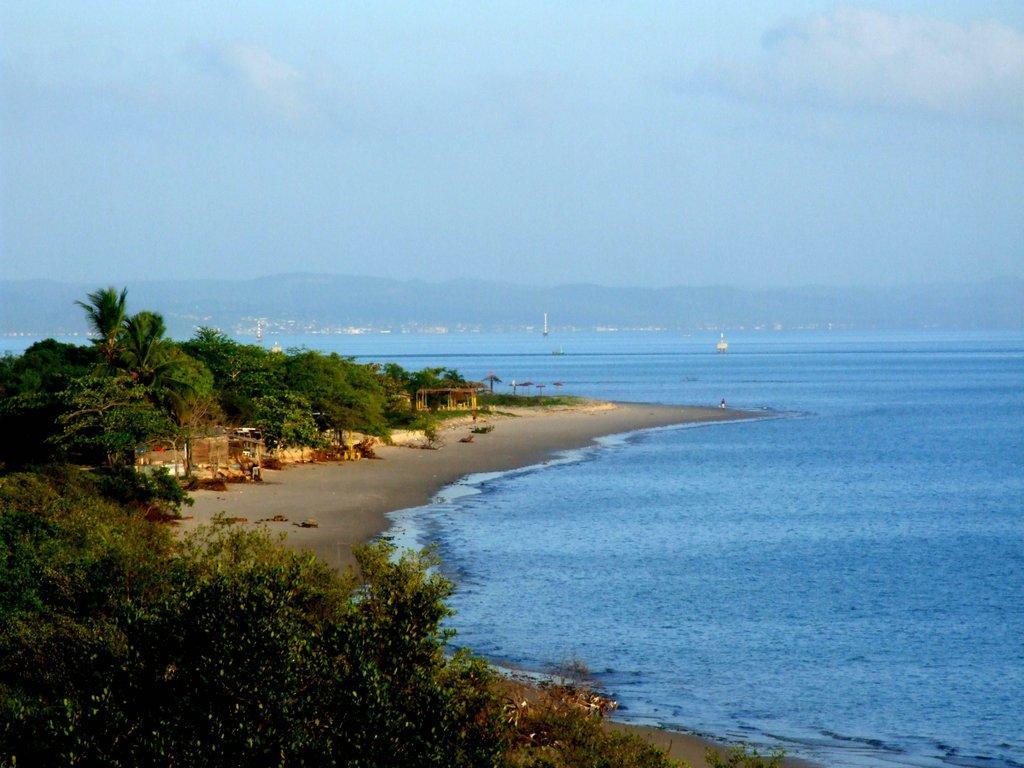Could you give a brief overview of what you see in this image? In this image, we can see some water and ships sailing on water. There are a few trees. We can see some sheds. There are a few hills. We can see the sky with clouds. We can see some umbrellas. 